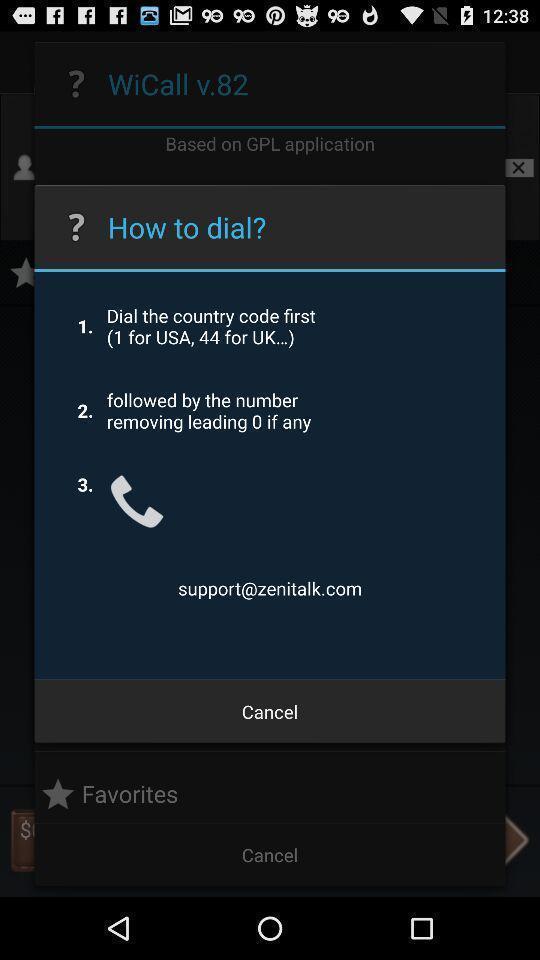Give me a summary of this screen capture. Pop-up showing instructions to dial the number. 